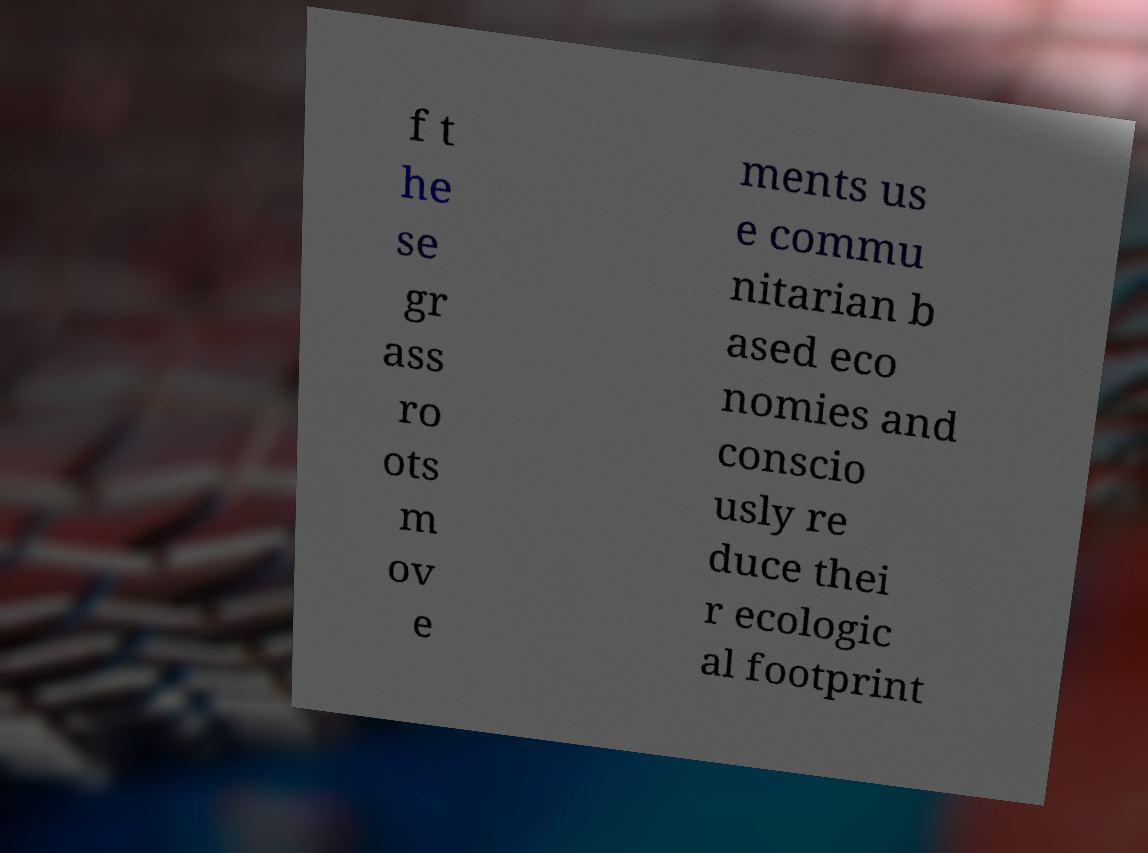Please read and relay the text visible in this image. What does it say? f t he se gr ass ro ots m ov e ments us e commu nitarian b ased eco nomies and conscio usly re duce thei r ecologic al footprint 